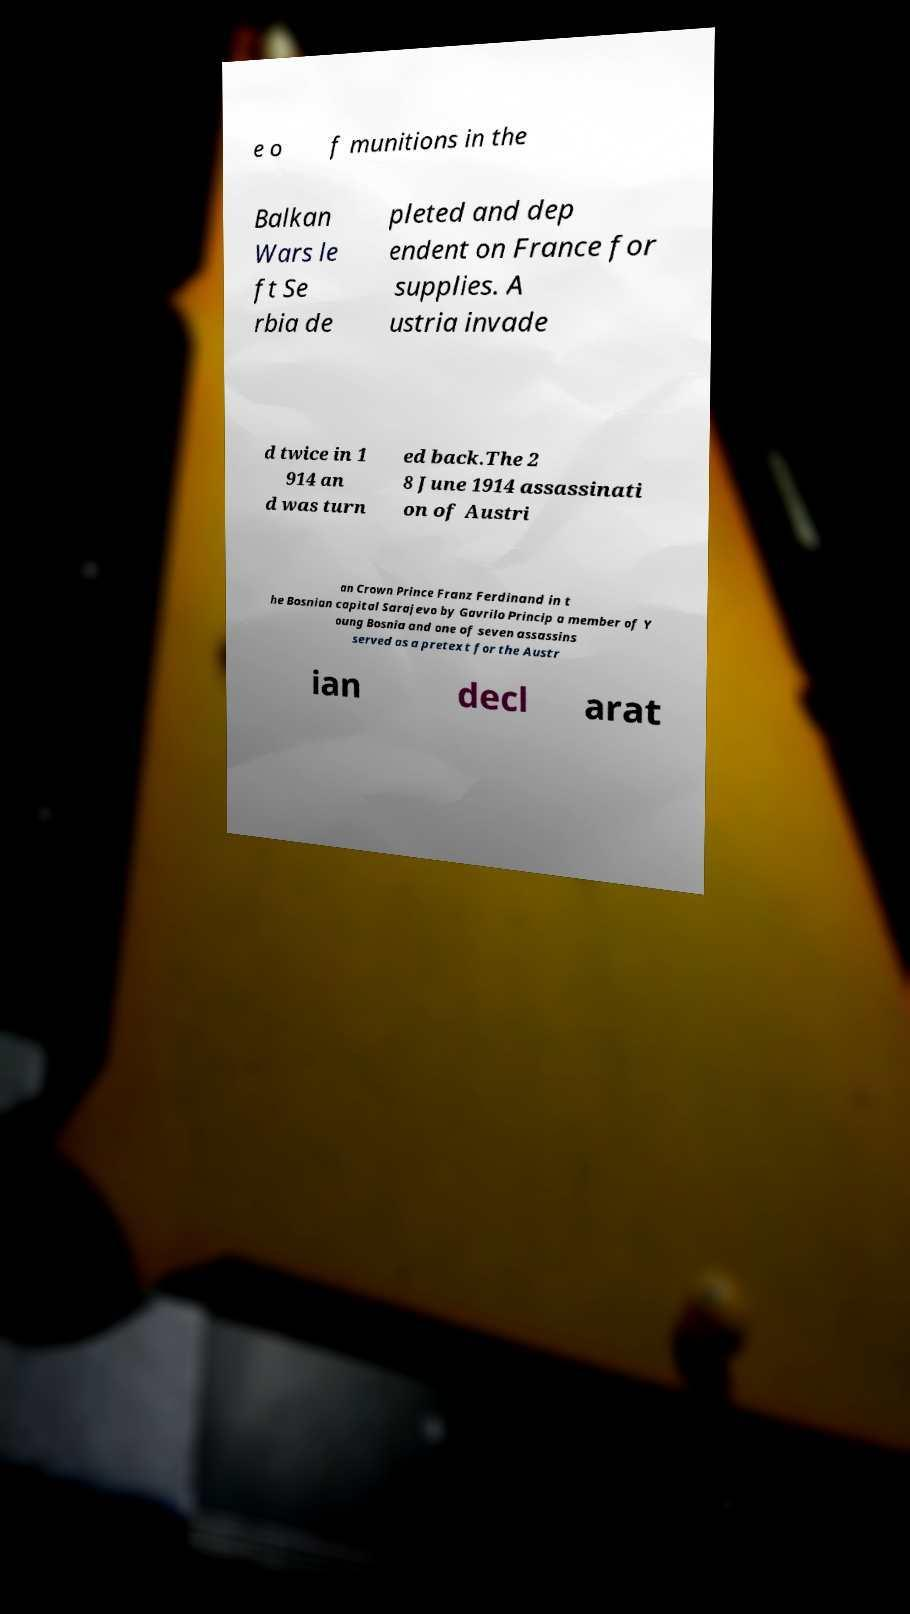Please read and relay the text visible in this image. What does it say? e o f munitions in the Balkan Wars le ft Se rbia de pleted and dep endent on France for supplies. A ustria invade d twice in 1 914 an d was turn ed back.The 2 8 June 1914 assassinati on of Austri an Crown Prince Franz Ferdinand in t he Bosnian capital Sarajevo by Gavrilo Princip a member of Y oung Bosnia and one of seven assassins served as a pretext for the Austr ian decl arat 